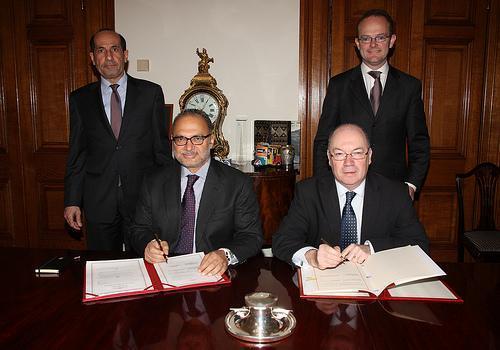How many clocks?
Give a very brief answer. 1. 